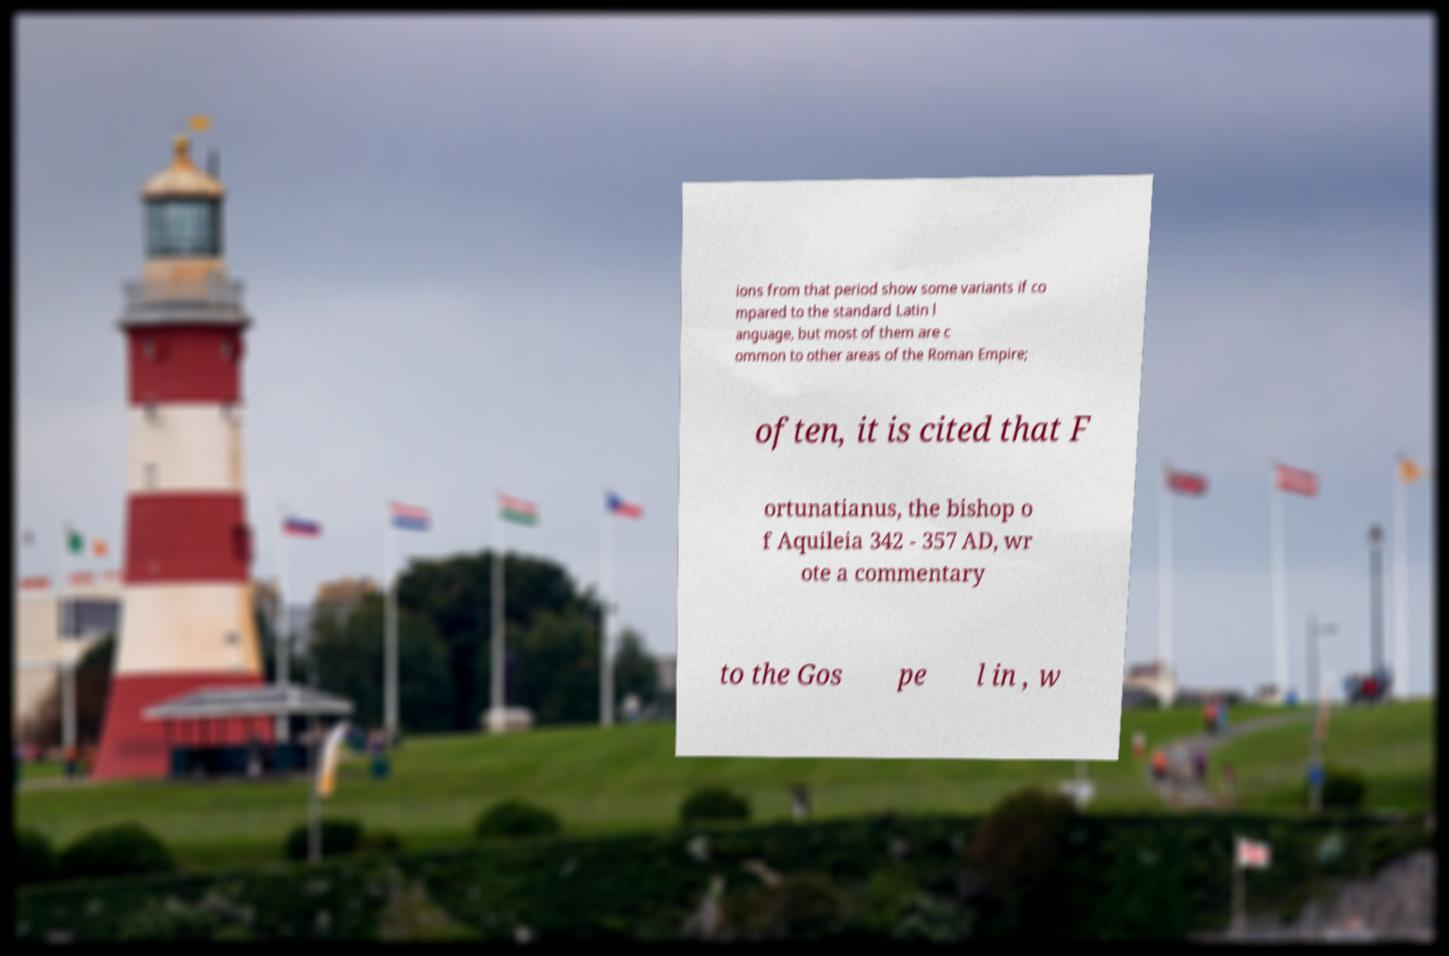For documentation purposes, I need the text within this image transcribed. Could you provide that? ions from that period show some variants if co mpared to the standard Latin l anguage, but most of them are c ommon to other areas of the Roman Empire; often, it is cited that F ortunatianus, the bishop o f Aquileia 342 - 357 AD, wr ote a commentary to the Gos pe l in , w 